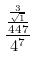<formula> <loc_0><loc_0><loc_500><loc_500>\frac { \frac { \frac { 3 } { \sqrt { 1 } } } { 4 4 7 } } { 4 ^ { 7 } }</formula> 